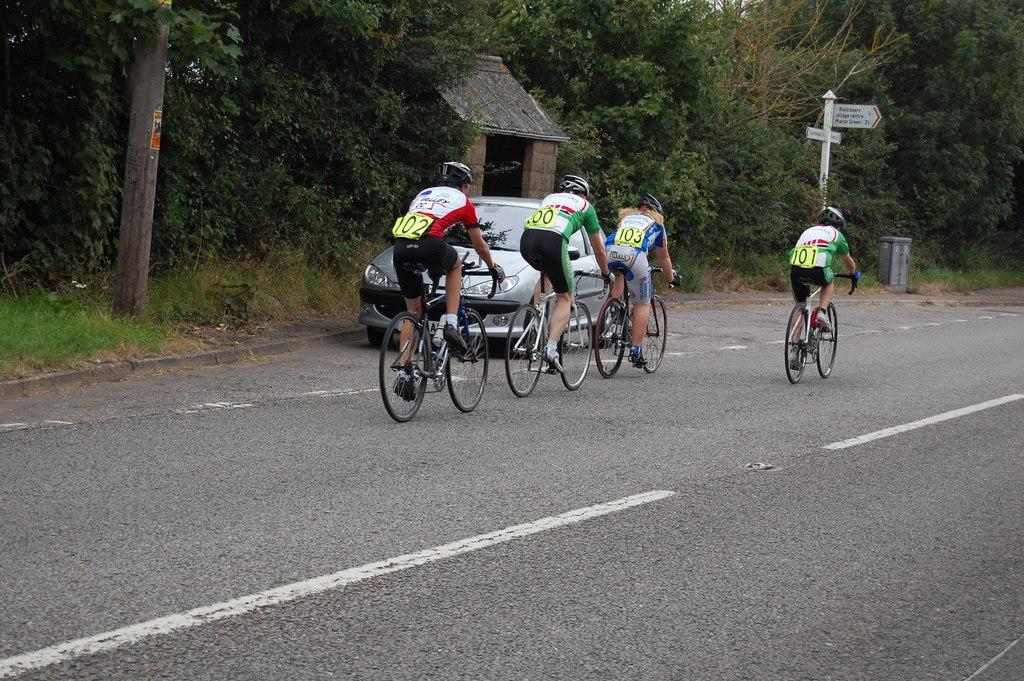Please provide a concise description of this image. In this image there are four persons cycling on the road. We can also see a car on the road. In the background there is a roof for shelter, poles and also trees. 